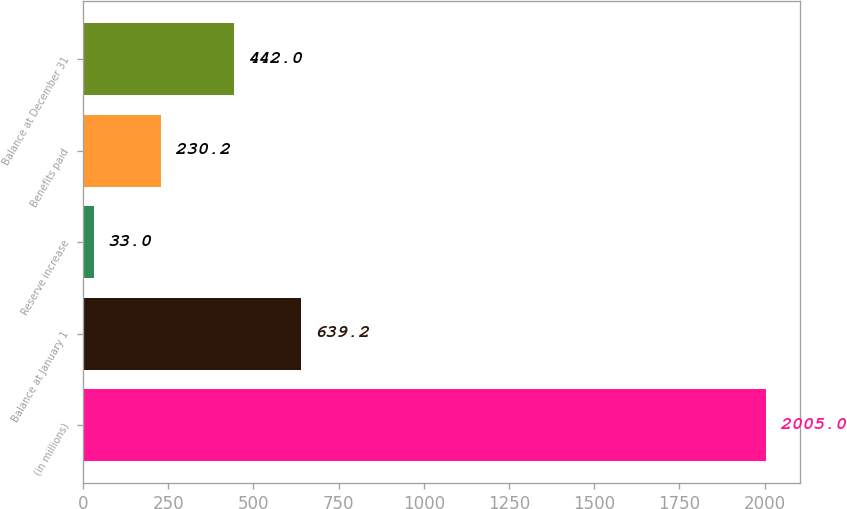Convert chart. <chart><loc_0><loc_0><loc_500><loc_500><bar_chart><fcel>(in millions)<fcel>Balance at January 1<fcel>Reserve increase<fcel>Benefits paid<fcel>Balance at December 31<nl><fcel>2005<fcel>639.2<fcel>33<fcel>230.2<fcel>442<nl></chart> 